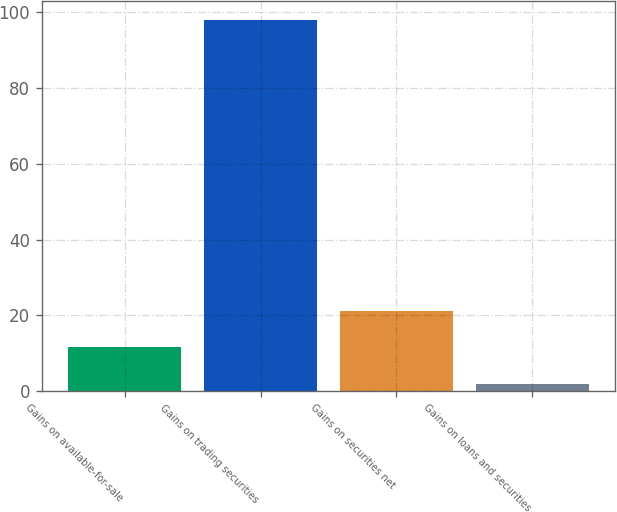<chart> <loc_0><loc_0><loc_500><loc_500><bar_chart><fcel>Gains on available-for-sale<fcel>Gains on trading securities<fcel>Gains on securities net<fcel>Gains on loans and securities<nl><fcel>11.6<fcel>98<fcel>21.2<fcel>2<nl></chart> 